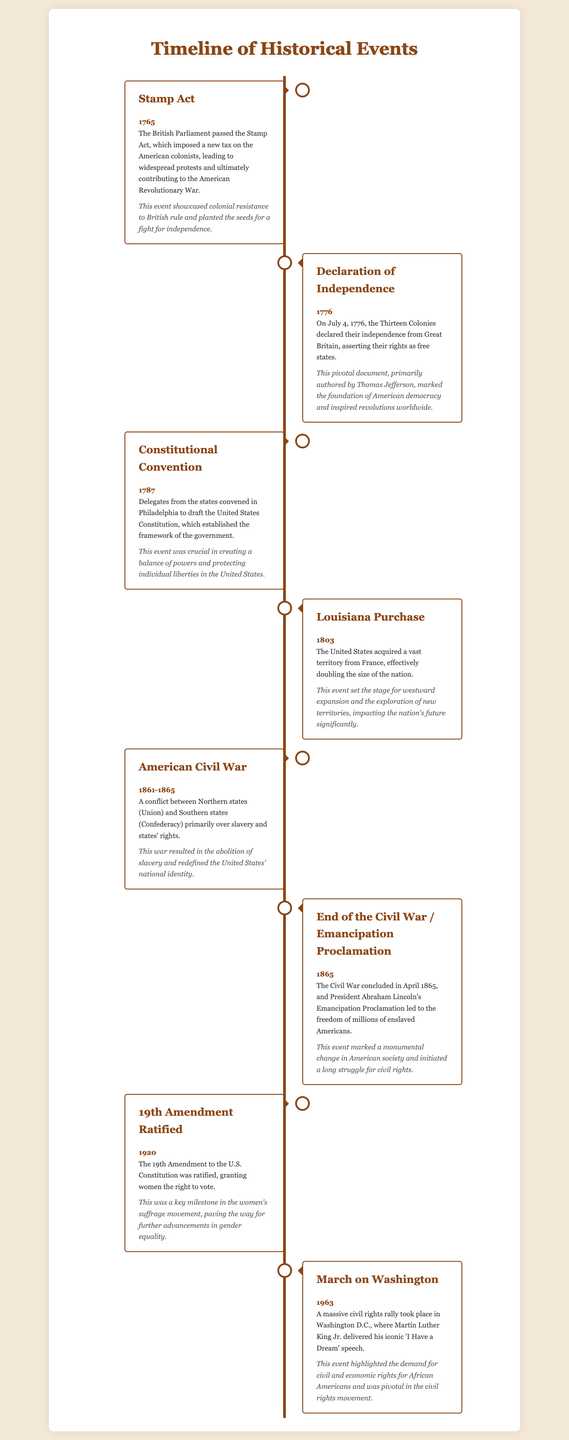What event was passed in 1765? The document lists the Stamp Act as the event passed in 1765.
Answer: Stamp Act What year did the Declaration of Independence occur? The timeline states that the Declaration of Independence took place in 1776.
Answer: 1776 Who authored the Declaration of Independence? According to the document, Thomas Jefferson primarily authored the Declaration of Independence.
Answer: Thomas Jefferson What significant purchase occurred in 1803? The timeline indicates that the Louisiana Purchase occurred in 1803.
Answer: Louisiana Purchase What was a primary cause of the American Civil War? The document mentions that slavery and states' rights were primary causes of the American Civil War.
Answer: Slavery Which amendment granted women's right to vote? The document specifies that the 19th Amendment granted women the right to vote.
Answer: 19th Amendment What was a major impact of the Emancipation Proclamation? It is noted that the Emancipation Proclamation led to the freedom of millions of enslaved Americans.
Answer: Freedom of millions What event took place in Washington D.C. in 1963? The timeline refers to the March on Washington as the event in 1963.
Answer: March on Washington What important speech was delivered during the March on Washington? The document states that Martin Luther King Jr. delivered the 'I Have a Dream' speech at the March on Washington.
Answer: 'I Have a Dream' speech What was the purpose of the Constitutional Convention? The document explains that the Constitutional Convention aimed to draft the United States Constitution.
Answer: Draft the Constitution 